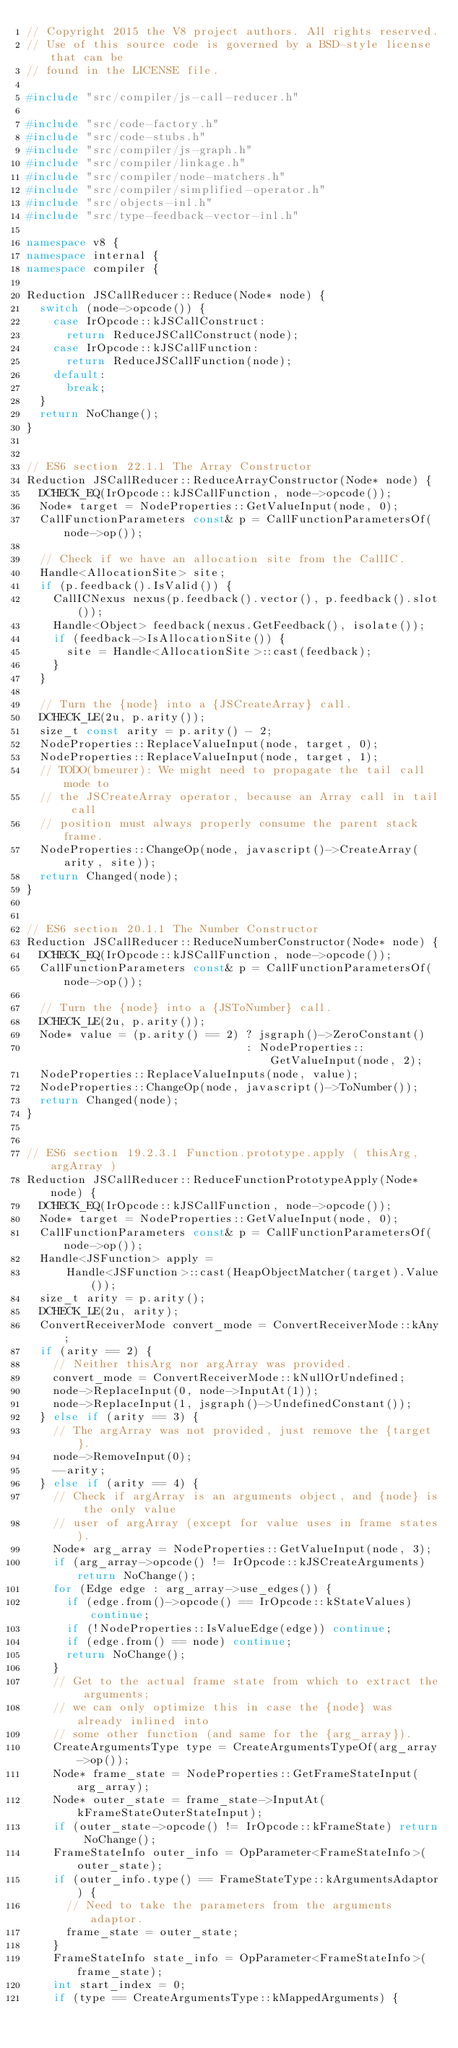<code> <loc_0><loc_0><loc_500><loc_500><_C++_>// Copyright 2015 the V8 project authors. All rights reserved.
// Use of this source code is governed by a BSD-style license that can be
// found in the LICENSE file.

#include "src/compiler/js-call-reducer.h"

#include "src/code-factory.h"
#include "src/code-stubs.h"
#include "src/compiler/js-graph.h"
#include "src/compiler/linkage.h"
#include "src/compiler/node-matchers.h"
#include "src/compiler/simplified-operator.h"
#include "src/objects-inl.h"
#include "src/type-feedback-vector-inl.h"

namespace v8 {
namespace internal {
namespace compiler {

Reduction JSCallReducer::Reduce(Node* node) {
  switch (node->opcode()) {
    case IrOpcode::kJSCallConstruct:
      return ReduceJSCallConstruct(node);
    case IrOpcode::kJSCallFunction:
      return ReduceJSCallFunction(node);
    default:
      break;
  }
  return NoChange();
}


// ES6 section 22.1.1 The Array Constructor
Reduction JSCallReducer::ReduceArrayConstructor(Node* node) {
  DCHECK_EQ(IrOpcode::kJSCallFunction, node->opcode());
  Node* target = NodeProperties::GetValueInput(node, 0);
  CallFunctionParameters const& p = CallFunctionParametersOf(node->op());

  // Check if we have an allocation site from the CallIC.
  Handle<AllocationSite> site;
  if (p.feedback().IsValid()) {
    CallICNexus nexus(p.feedback().vector(), p.feedback().slot());
    Handle<Object> feedback(nexus.GetFeedback(), isolate());
    if (feedback->IsAllocationSite()) {
      site = Handle<AllocationSite>::cast(feedback);
    }
  }

  // Turn the {node} into a {JSCreateArray} call.
  DCHECK_LE(2u, p.arity());
  size_t const arity = p.arity() - 2;
  NodeProperties::ReplaceValueInput(node, target, 0);
  NodeProperties::ReplaceValueInput(node, target, 1);
  // TODO(bmeurer): We might need to propagate the tail call mode to
  // the JSCreateArray operator, because an Array call in tail call
  // position must always properly consume the parent stack frame.
  NodeProperties::ChangeOp(node, javascript()->CreateArray(arity, site));
  return Changed(node);
}


// ES6 section 20.1.1 The Number Constructor
Reduction JSCallReducer::ReduceNumberConstructor(Node* node) {
  DCHECK_EQ(IrOpcode::kJSCallFunction, node->opcode());
  CallFunctionParameters const& p = CallFunctionParametersOf(node->op());

  // Turn the {node} into a {JSToNumber} call.
  DCHECK_LE(2u, p.arity());
  Node* value = (p.arity() == 2) ? jsgraph()->ZeroConstant()
                                 : NodeProperties::GetValueInput(node, 2);
  NodeProperties::ReplaceValueInputs(node, value);
  NodeProperties::ChangeOp(node, javascript()->ToNumber());
  return Changed(node);
}


// ES6 section 19.2.3.1 Function.prototype.apply ( thisArg, argArray )
Reduction JSCallReducer::ReduceFunctionPrototypeApply(Node* node) {
  DCHECK_EQ(IrOpcode::kJSCallFunction, node->opcode());
  Node* target = NodeProperties::GetValueInput(node, 0);
  CallFunctionParameters const& p = CallFunctionParametersOf(node->op());
  Handle<JSFunction> apply =
      Handle<JSFunction>::cast(HeapObjectMatcher(target).Value());
  size_t arity = p.arity();
  DCHECK_LE(2u, arity);
  ConvertReceiverMode convert_mode = ConvertReceiverMode::kAny;
  if (arity == 2) {
    // Neither thisArg nor argArray was provided.
    convert_mode = ConvertReceiverMode::kNullOrUndefined;
    node->ReplaceInput(0, node->InputAt(1));
    node->ReplaceInput(1, jsgraph()->UndefinedConstant());
  } else if (arity == 3) {
    // The argArray was not provided, just remove the {target}.
    node->RemoveInput(0);
    --arity;
  } else if (arity == 4) {
    // Check if argArray is an arguments object, and {node} is the only value
    // user of argArray (except for value uses in frame states).
    Node* arg_array = NodeProperties::GetValueInput(node, 3);
    if (arg_array->opcode() != IrOpcode::kJSCreateArguments) return NoChange();
    for (Edge edge : arg_array->use_edges()) {
      if (edge.from()->opcode() == IrOpcode::kStateValues) continue;
      if (!NodeProperties::IsValueEdge(edge)) continue;
      if (edge.from() == node) continue;
      return NoChange();
    }
    // Get to the actual frame state from which to extract the arguments;
    // we can only optimize this in case the {node} was already inlined into
    // some other function (and same for the {arg_array}).
    CreateArgumentsType type = CreateArgumentsTypeOf(arg_array->op());
    Node* frame_state = NodeProperties::GetFrameStateInput(arg_array);
    Node* outer_state = frame_state->InputAt(kFrameStateOuterStateInput);
    if (outer_state->opcode() != IrOpcode::kFrameState) return NoChange();
    FrameStateInfo outer_info = OpParameter<FrameStateInfo>(outer_state);
    if (outer_info.type() == FrameStateType::kArgumentsAdaptor) {
      // Need to take the parameters from the arguments adaptor.
      frame_state = outer_state;
    }
    FrameStateInfo state_info = OpParameter<FrameStateInfo>(frame_state);
    int start_index = 0;
    if (type == CreateArgumentsType::kMappedArguments) {</code> 